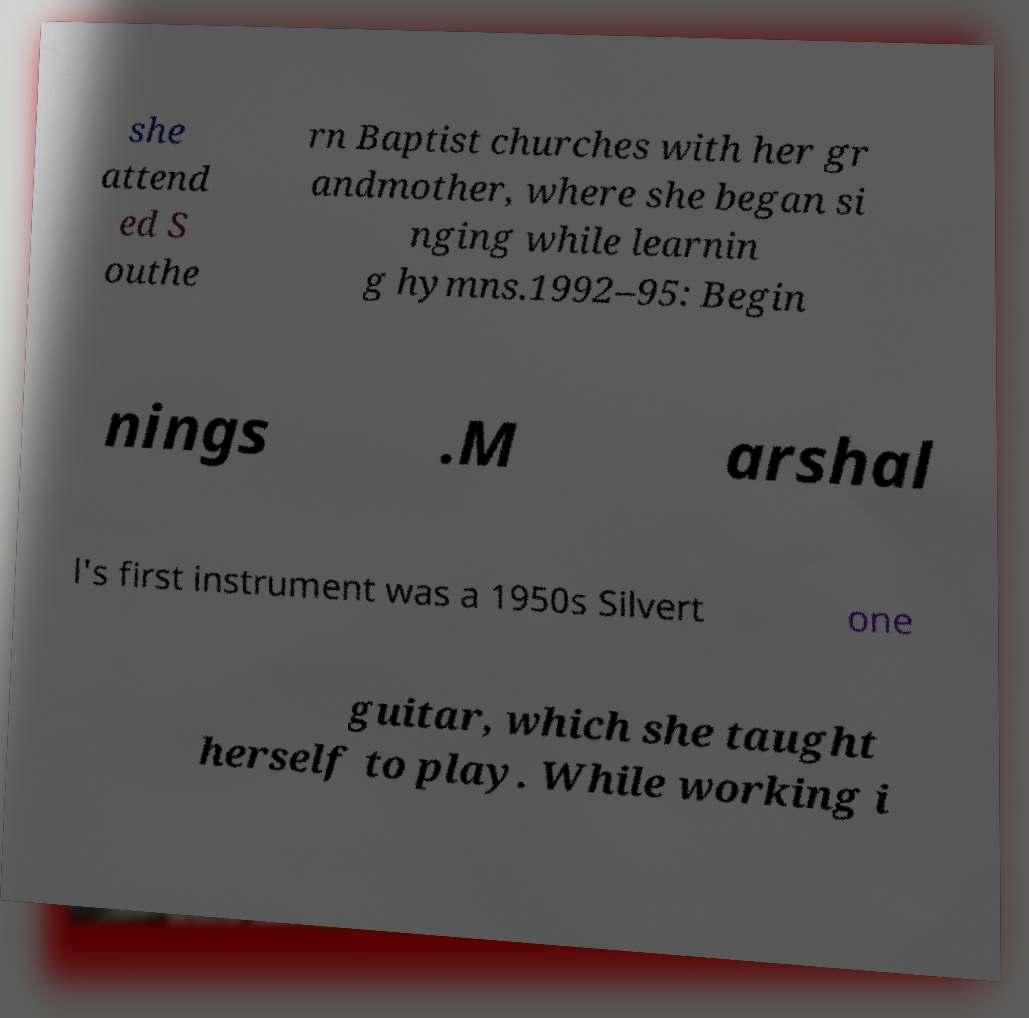What messages or text are displayed in this image? I need them in a readable, typed format. she attend ed S outhe rn Baptist churches with her gr andmother, where she began si nging while learnin g hymns.1992–95: Begin nings .M arshal l's first instrument was a 1950s Silvert one guitar, which she taught herself to play. While working i 